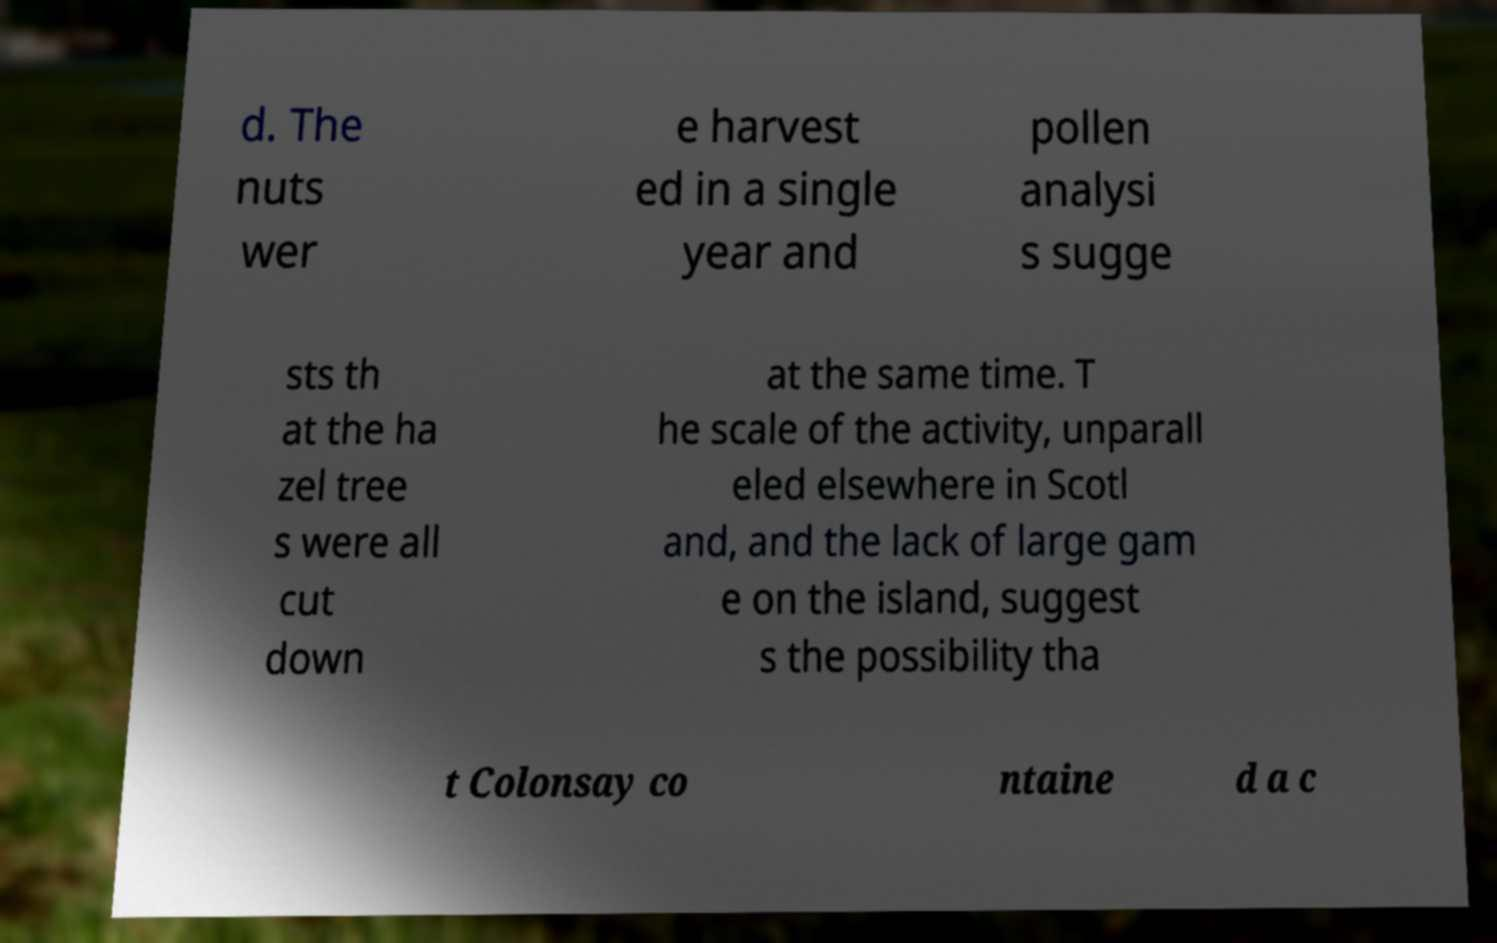Could you extract and type out the text from this image? d. The nuts wer e harvest ed in a single year and pollen analysi s sugge sts th at the ha zel tree s were all cut down at the same time. T he scale of the activity, unparall eled elsewhere in Scotl and, and the lack of large gam e on the island, suggest s the possibility tha t Colonsay co ntaine d a c 